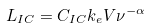<formula> <loc_0><loc_0><loc_500><loc_500>L _ { I C } = C _ { I C } k _ { e } V \nu ^ { - \alpha }</formula> 